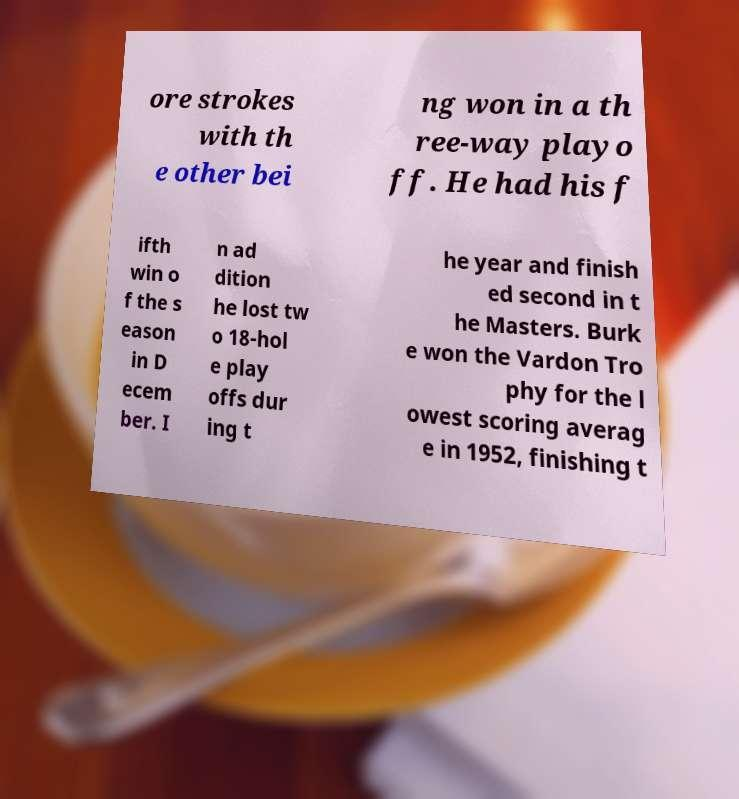I need the written content from this picture converted into text. Can you do that? ore strokes with th e other bei ng won in a th ree-way playo ff. He had his f ifth win o f the s eason in D ecem ber. I n ad dition he lost tw o 18-hol e play offs dur ing t he year and finish ed second in t he Masters. Burk e won the Vardon Tro phy for the l owest scoring averag e in 1952, finishing t 